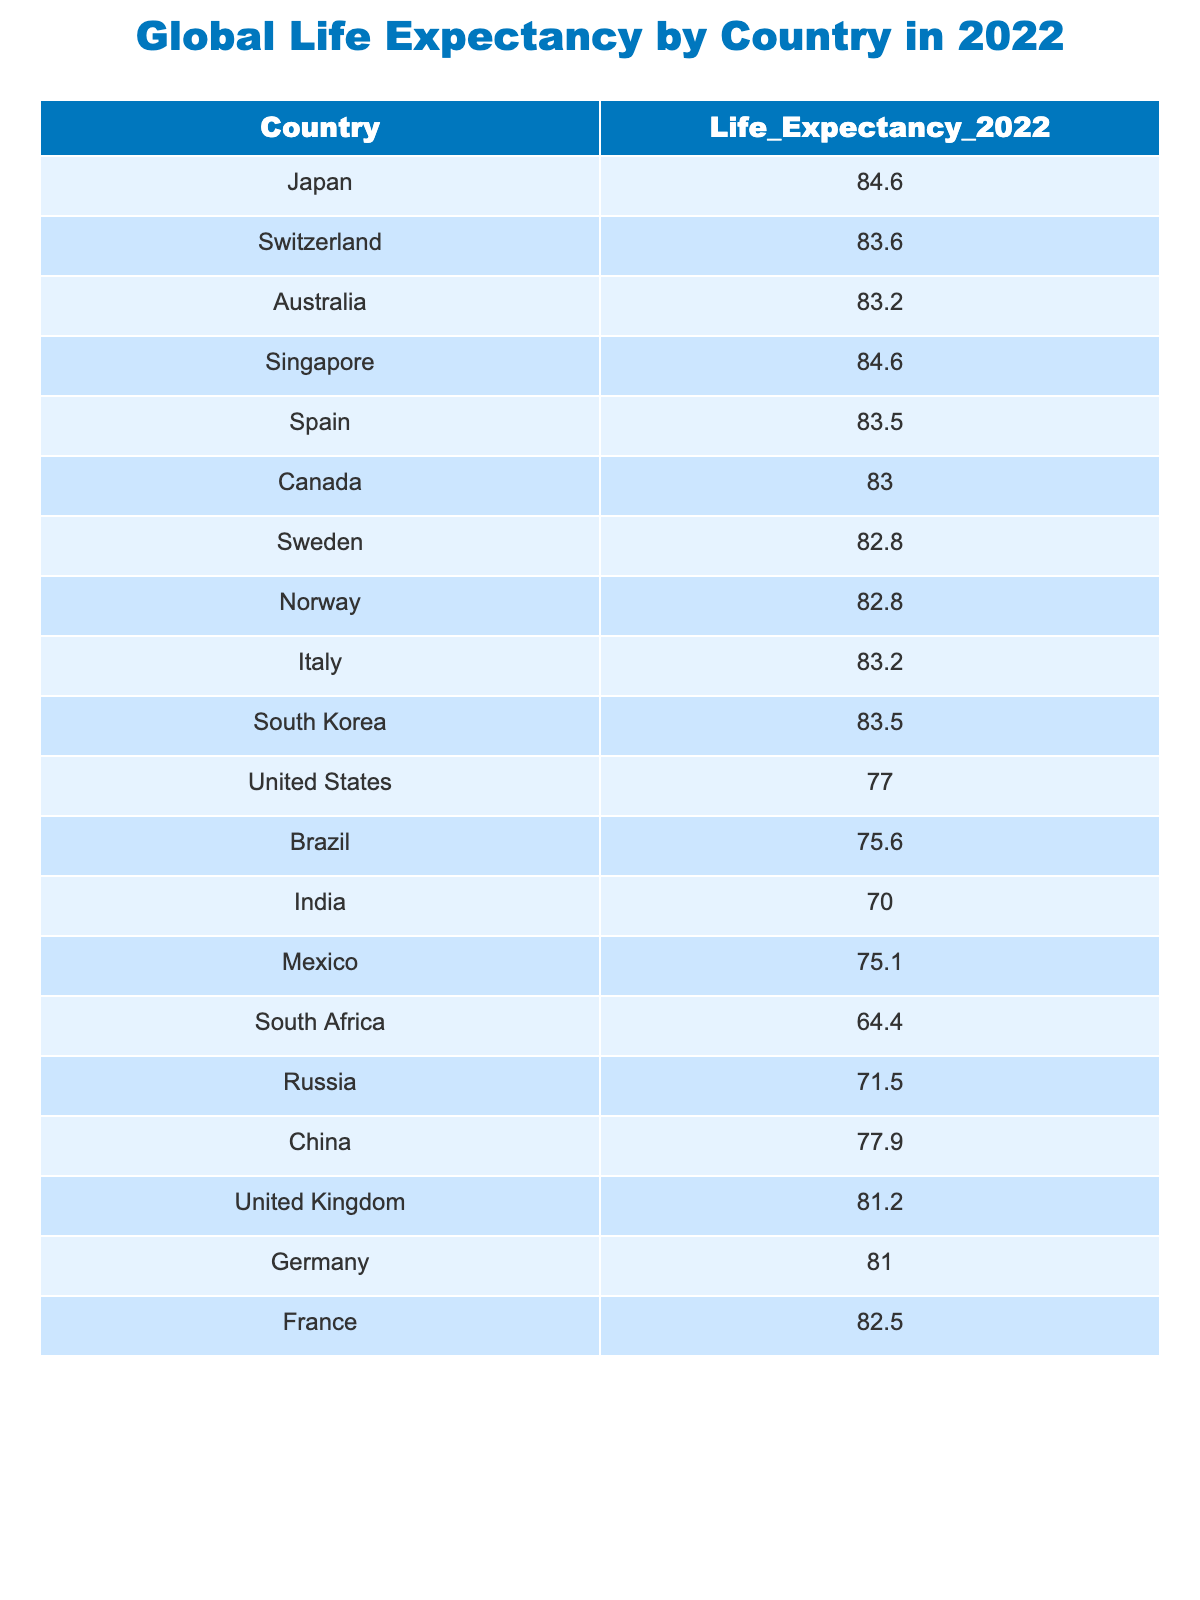What is the life expectancy of Japan in 2022? The table lists Japan's life expectancy value directly, which is 84.6 years.
Answer: 84.6 Which country has the lowest life expectancy in 2022? By checking all the values in the table, South Africa shows the lowest life expectancy at 64.4 years.
Answer: South Africa What is the difference in life expectancy between the United States and Canada? The life expectancy of the United States is 77.0 years, and that of Canada is 83.0 years. The difference is calculated as 83.0 - 77.0 = 6.0 years.
Answer: 6.0 Is the life expectancy of India higher than that of Brazil? India has a life expectancy of 70.0 years, while Brazil has a life expectancy of 75.6 years. Since 70.0 is less than 75.6, this statement is false.
Answer: No What is the average life expectancy of the top three countries with the highest life expectancy? The top three countries are Japan (84.6), Switzerland (83.6), and Singapore (84.6). The sum of their life expectancies is 84.6 + 83.6 + 84.6 = 252.8. To find the average, we divide by 3: 252.8 / 3 = 84.27.
Answer: 84.27 Is the life expectancy of Norway greater than 82 years? Norway's life expectancy is 82.8 years, which is greater than 82 years, making this statement true.
Answer: Yes What is the median life expectancy among the listed countries? First, arrange the life expectancy values in increasing order: 64.4, 70.0, 71.5, 75.1, 75.6, 77.0, 77.9, 81.0, 81.2, 82.5, 82.8, 82.8, 83.2, 83.2, 83.5, 83.5, 84.6, 84.6. With 18 values, the median is the average of the 9th and 10th values: (81.0 + 81.2) / 2 = 81.1.
Answer: 81.1 How many countries have a life expectancy greater than 80 years? By checking each life expectancy value, we find that Japan, Switzerland, Australia, Singapore, Spain, Canada, Sweden, Norway, Italy, South Korea, and France all exceed 80 years, resulting in a total of 11 countries.
Answer: 11 Which country has a life expectancy of 82.5 years? By reviewing the table, France has a listed life expectancy of 82.5 years.
Answer: France 